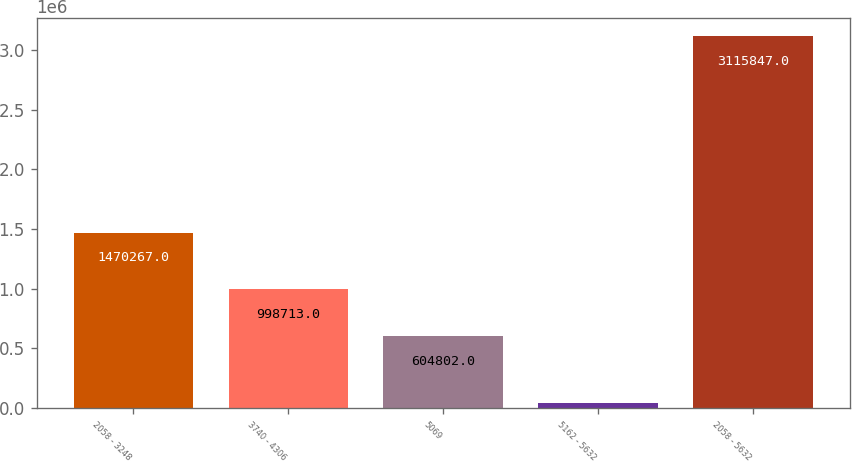Convert chart. <chart><loc_0><loc_0><loc_500><loc_500><bar_chart><fcel>2058 - 3248<fcel>3740 - 4306<fcel>5069<fcel>5162 - 5632<fcel>2058 - 5632<nl><fcel>1.47027e+06<fcel>998713<fcel>604802<fcel>42065<fcel>3.11585e+06<nl></chart> 